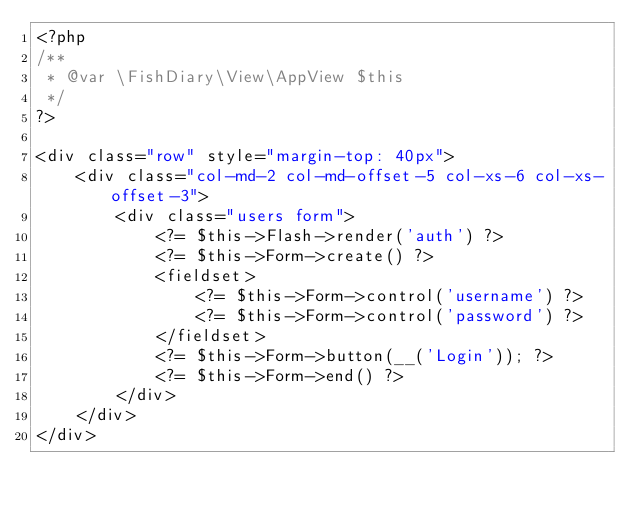<code> <loc_0><loc_0><loc_500><loc_500><_PHP_><?php
/**
 * @var \FishDiary\View\AppView $this
 */
?>

<div class="row" style="margin-top: 40px">
    <div class="col-md-2 col-md-offset-5 col-xs-6 col-xs-offset-3">
        <div class="users form">
            <?= $this->Flash->render('auth') ?>
            <?= $this->Form->create() ?>
            <fieldset>
                <?= $this->Form->control('username') ?>
                <?= $this->Form->control('password') ?>
            </fieldset>
            <?= $this->Form->button(__('Login')); ?>
            <?= $this->Form->end() ?>
        </div>
    </div>
</div></code> 